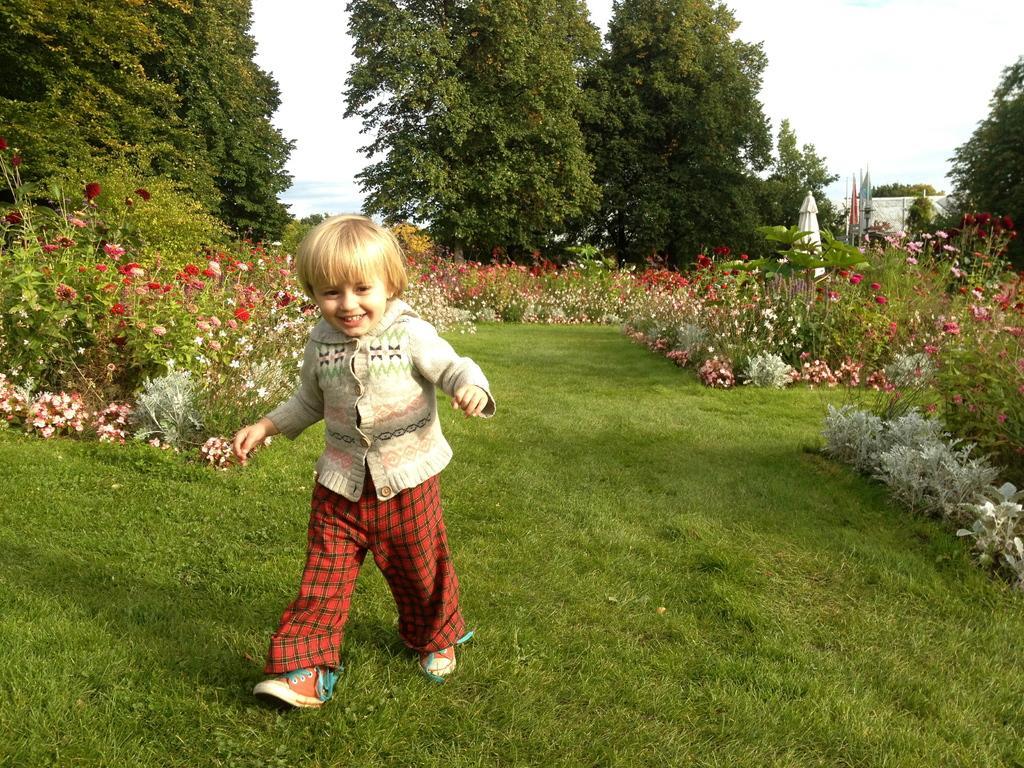Could you give a brief overview of what you see in this image? In this picture there is a boy who is wearing sweater and shoe. He is walking on the ground. On the bottom we can see. In the back we can see trees, flags, flowers, plants and other objects. At the top right corner we can see sky and clouds. 